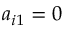<formula> <loc_0><loc_0><loc_500><loc_500>a _ { i 1 } = 0</formula> 